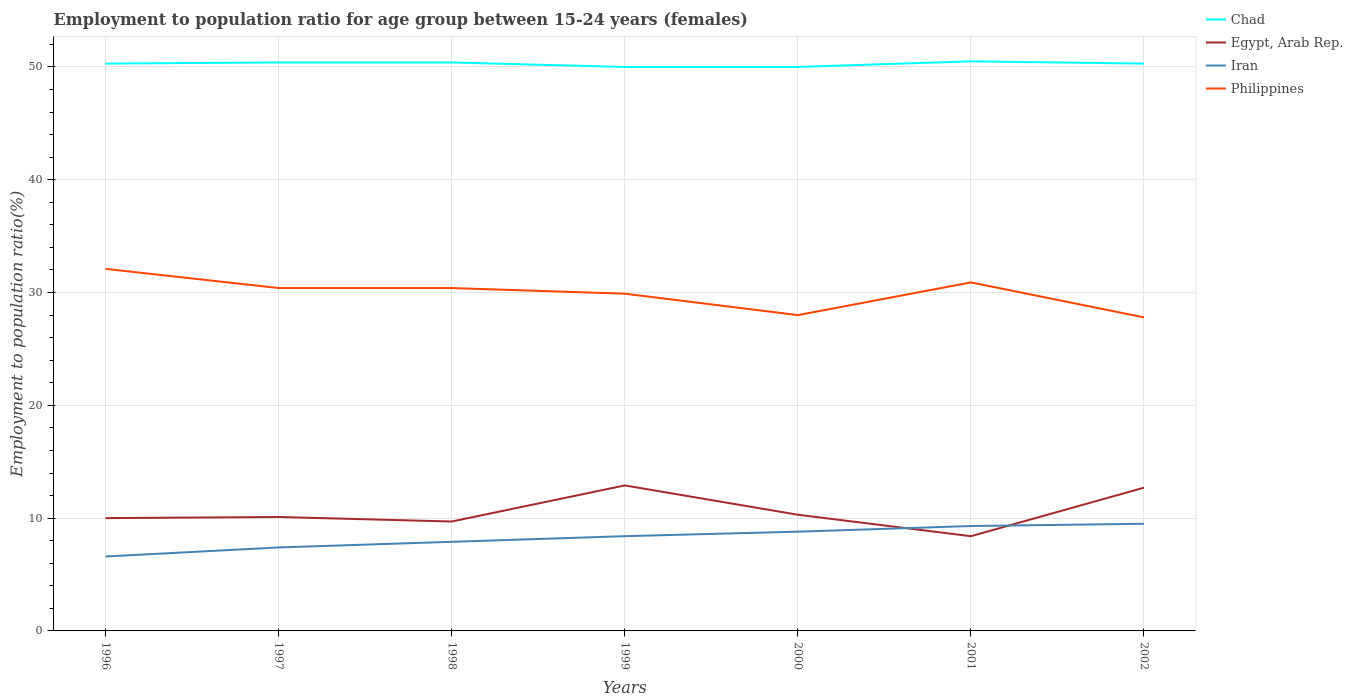How many different coloured lines are there?
Your response must be concise. 4. Across all years, what is the maximum employment to population ratio in Iran?
Give a very brief answer. 6.6. In which year was the employment to population ratio in Iran maximum?
Offer a very short reply. 1996. What is the total employment to population ratio in Egypt, Arab Rep. in the graph?
Provide a succinct answer. 4.5. What is the difference between the highest and the second highest employment to population ratio in Iran?
Provide a short and direct response. 2.9. How many lines are there?
Make the answer very short. 4. How many years are there in the graph?
Offer a terse response. 7. What is the difference between two consecutive major ticks on the Y-axis?
Offer a very short reply. 10. Are the values on the major ticks of Y-axis written in scientific E-notation?
Make the answer very short. No. Does the graph contain any zero values?
Make the answer very short. No. How many legend labels are there?
Your answer should be compact. 4. What is the title of the graph?
Give a very brief answer. Employment to population ratio for age group between 15-24 years (females). What is the label or title of the X-axis?
Keep it short and to the point. Years. What is the label or title of the Y-axis?
Provide a short and direct response. Employment to population ratio(%). What is the Employment to population ratio(%) in Chad in 1996?
Ensure brevity in your answer.  50.3. What is the Employment to population ratio(%) of Egypt, Arab Rep. in 1996?
Keep it short and to the point. 10. What is the Employment to population ratio(%) in Iran in 1996?
Offer a very short reply. 6.6. What is the Employment to population ratio(%) of Philippines in 1996?
Provide a short and direct response. 32.1. What is the Employment to population ratio(%) of Chad in 1997?
Your answer should be compact. 50.4. What is the Employment to population ratio(%) in Egypt, Arab Rep. in 1997?
Give a very brief answer. 10.1. What is the Employment to population ratio(%) of Iran in 1997?
Offer a very short reply. 7.4. What is the Employment to population ratio(%) in Philippines in 1997?
Offer a terse response. 30.4. What is the Employment to population ratio(%) in Chad in 1998?
Your answer should be compact. 50.4. What is the Employment to population ratio(%) of Egypt, Arab Rep. in 1998?
Your response must be concise. 9.7. What is the Employment to population ratio(%) in Iran in 1998?
Make the answer very short. 7.9. What is the Employment to population ratio(%) of Philippines in 1998?
Provide a succinct answer. 30.4. What is the Employment to population ratio(%) of Chad in 1999?
Offer a very short reply. 50. What is the Employment to population ratio(%) of Egypt, Arab Rep. in 1999?
Offer a terse response. 12.9. What is the Employment to population ratio(%) of Iran in 1999?
Provide a succinct answer. 8.4. What is the Employment to population ratio(%) of Philippines in 1999?
Offer a terse response. 29.9. What is the Employment to population ratio(%) of Egypt, Arab Rep. in 2000?
Provide a succinct answer. 10.3. What is the Employment to population ratio(%) of Iran in 2000?
Ensure brevity in your answer.  8.8. What is the Employment to population ratio(%) in Chad in 2001?
Your response must be concise. 50.5. What is the Employment to population ratio(%) of Egypt, Arab Rep. in 2001?
Keep it short and to the point. 8.4. What is the Employment to population ratio(%) in Iran in 2001?
Make the answer very short. 9.3. What is the Employment to population ratio(%) of Philippines in 2001?
Ensure brevity in your answer.  30.9. What is the Employment to population ratio(%) of Chad in 2002?
Your answer should be very brief. 50.3. What is the Employment to population ratio(%) in Egypt, Arab Rep. in 2002?
Your answer should be compact. 12.7. What is the Employment to population ratio(%) of Iran in 2002?
Your answer should be compact. 9.5. What is the Employment to population ratio(%) of Philippines in 2002?
Your answer should be compact. 27.8. Across all years, what is the maximum Employment to population ratio(%) in Chad?
Your response must be concise. 50.5. Across all years, what is the maximum Employment to population ratio(%) in Egypt, Arab Rep.?
Provide a succinct answer. 12.9. Across all years, what is the maximum Employment to population ratio(%) of Iran?
Your answer should be very brief. 9.5. Across all years, what is the maximum Employment to population ratio(%) in Philippines?
Ensure brevity in your answer.  32.1. Across all years, what is the minimum Employment to population ratio(%) in Egypt, Arab Rep.?
Your response must be concise. 8.4. Across all years, what is the minimum Employment to population ratio(%) in Iran?
Your answer should be very brief. 6.6. Across all years, what is the minimum Employment to population ratio(%) in Philippines?
Keep it short and to the point. 27.8. What is the total Employment to population ratio(%) of Chad in the graph?
Provide a succinct answer. 351.9. What is the total Employment to population ratio(%) in Egypt, Arab Rep. in the graph?
Your answer should be compact. 74.1. What is the total Employment to population ratio(%) in Iran in the graph?
Keep it short and to the point. 57.9. What is the total Employment to population ratio(%) of Philippines in the graph?
Your answer should be compact. 209.5. What is the difference between the Employment to population ratio(%) of Chad in 1996 and that in 1997?
Give a very brief answer. -0.1. What is the difference between the Employment to population ratio(%) in Philippines in 1996 and that in 1997?
Offer a very short reply. 1.7. What is the difference between the Employment to population ratio(%) of Iran in 1996 and that in 1998?
Make the answer very short. -1.3. What is the difference between the Employment to population ratio(%) in Philippines in 1996 and that in 1998?
Offer a very short reply. 1.7. What is the difference between the Employment to population ratio(%) in Chad in 1996 and that in 1999?
Provide a short and direct response. 0.3. What is the difference between the Employment to population ratio(%) of Iran in 1996 and that in 1999?
Your response must be concise. -1.8. What is the difference between the Employment to population ratio(%) of Philippines in 1996 and that in 2000?
Provide a short and direct response. 4.1. What is the difference between the Employment to population ratio(%) of Philippines in 1996 and that in 2001?
Your response must be concise. 1.2. What is the difference between the Employment to population ratio(%) in Chad in 1996 and that in 2002?
Offer a terse response. 0. What is the difference between the Employment to population ratio(%) in Iran in 1996 and that in 2002?
Make the answer very short. -2.9. What is the difference between the Employment to population ratio(%) in Chad in 1997 and that in 1998?
Your answer should be compact. 0. What is the difference between the Employment to population ratio(%) of Philippines in 1997 and that in 1998?
Offer a terse response. 0. What is the difference between the Employment to population ratio(%) in Chad in 1997 and that in 1999?
Ensure brevity in your answer.  0.4. What is the difference between the Employment to population ratio(%) of Egypt, Arab Rep. in 1997 and that in 1999?
Provide a short and direct response. -2.8. What is the difference between the Employment to population ratio(%) in Philippines in 1997 and that in 1999?
Provide a succinct answer. 0.5. What is the difference between the Employment to population ratio(%) of Chad in 1997 and that in 2000?
Your answer should be very brief. 0.4. What is the difference between the Employment to population ratio(%) in Egypt, Arab Rep. in 1997 and that in 2000?
Offer a very short reply. -0.2. What is the difference between the Employment to population ratio(%) of Iran in 1997 and that in 2000?
Give a very brief answer. -1.4. What is the difference between the Employment to population ratio(%) of Philippines in 1997 and that in 2001?
Your answer should be very brief. -0.5. What is the difference between the Employment to population ratio(%) in Chad in 1997 and that in 2002?
Offer a terse response. 0.1. What is the difference between the Employment to population ratio(%) of Egypt, Arab Rep. in 1997 and that in 2002?
Offer a very short reply. -2.6. What is the difference between the Employment to population ratio(%) of Philippines in 1997 and that in 2002?
Offer a very short reply. 2.6. What is the difference between the Employment to population ratio(%) in Egypt, Arab Rep. in 1998 and that in 1999?
Provide a short and direct response. -3.2. What is the difference between the Employment to population ratio(%) in Iran in 1998 and that in 1999?
Give a very brief answer. -0.5. What is the difference between the Employment to population ratio(%) of Philippines in 1998 and that in 1999?
Provide a short and direct response. 0.5. What is the difference between the Employment to population ratio(%) in Chad in 1998 and that in 2000?
Offer a very short reply. 0.4. What is the difference between the Employment to population ratio(%) of Chad in 1998 and that in 2001?
Keep it short and to the point. -0.1. What is the difference between the Employment to population ratio(%) in Egypt, Arab Rep. in 1998 and that in 2001?
Make the answer very short. 1.3. What is the difference between the Employment to population ratio(%) of Iran in 1998 and that in 2001?
Give a very brief answer. -1.4. What is the difference between the Employment to population ratio(%) of Iran in 1998 and that in 2002?
Provide a short and direct response. -1.6. What is the difference between the Employment to population ratio(%) in Egypt, Arab Rep. in 1999 and that in 2000?
Give a very brief answer. 2.6. What is the difference between the Employment to population ratio(%) of Iran in 1999 and that in 2000?
Your response must be concise. -0.4. What is the difference between the Employment to population ratio(%) in Philippines in 1999 and that in 2000?
Make the answer very short. 1.9. What is the difference between the Employment to population ratio(%) in Chad in 1999 and that in 2001?
Your response must be concise. -0.5. What is the difference between the Employment to population ratio(%) in Egypt, Arab Rep. in 1999 and that in 2002?
Provide a short and direct response. 0.2. What is the difference between the Employment to population ratio(%) of Iran in 1999 and that in 2002?
Ensure brevity in your answer.  -1.1. What is the difference between the Employment to population ratio(%) of Iran in 2000 and that in 2001?
Make the answer very short. -0.5. What is the difference between the Employment to population ratio(%) in Philippines in 2000 and that in 2001?
Make the answer very short. -2.9. What is the difference between the Employment to population ratio(%) of Chad in 2000 and that in 2002?
Ensure brevity in your answer.  -0.3. What is the difference between the Employment to population ratio(%) in Iran in 2000 and that in 2002?
Provide a short and direct response. -0.7. What is the difference between the Employment to population ratio(%) in Philippines in 2000 and that in 2002?
Provide a short and direct response. 0.2. What is the difference between the Employment to population ratio(%) in Egypt, Arab Rep. in 2001 and that in 2002?
Offer a terse response. -4.3. What is the difference between the Employment to population ratio(%) of Chad in 1996 and the Employment to population ratio(%) of Egypt, Arab Rep. in 1997?
Offer a very short reply. 40.2. What is the difference between the Employment to population ratio(%) of Chad in 1996 and the Employment to population ratio(%) of Iran in 1997?
Your answer should be compact. 42.9. What is the difference between the Employment to population ratio(%) in Chad in 1996 and the Employment to population ratio(%) in Philippines in 1997?
Provide a succinct answer. 19.9. What is the difference between the Employment to population ratio(%) of Egypt, Arab Rep. in 1996 and the Employment to population ratio(%) of Philippines in 1997?
Your answer should be compact. -20.4. What is the difference between the Employment to population ratio(%) of Iran in 1996 and the Employment to population ratio(%) of Philippines in 1997?
Provide a short and direct response. -23.8. What is the difference between the Employment to population ratio(%) in Chad in 1996 and the Employment to population ratio(%) in Egypt, Arab Rep. in 1998?
Provide a succinct answer. 40.6. What is the difference between the Employment to population ratio(%) in Chad in 1996 and the Employment to population ratio(%) in Iran in 1998?
Provide a succinct answer. 42.4. What is the difference between the Employment to population ratio(%) of Chad in 1996 and the Employment to population ratio(%) of Philippines in 1998?
Your answer should be very brief. 19.9. What is the difference between the Employment to population ratio(%) in Egypt, Arab Rep. in 1996 and the Employment to population ratio(%) in Iran in 1998?
Keep it short and to the point. 2.1. What is the difference between the Employment to population ratio(%) of Egypt, Arab Rep. in 1996 and the Employment to population ratio(%) of Philippines in 1998?
Your answer should be compact. -20.4. What is the difference between the Employment to population ratio(%) of Iran in 1996 and the Employment to population ratio(%) of Philippines in 1998?
Your response must be concise. -23.8. What is the difference between the Employment to population ratio(%) in Chad in 1996 and the Employment to population ratio(%) in Egypt, Arab Rep. in 1999?
Your answer should be very brief. 37.4. What is the difference between the Employment to population ratio(%) in Chad in 1996 and the Employment to population ratio(%) in Iran in 1999?
Your answer should be compact. 41.9. What is the difference between the Employment to population ratio(%) of Chad in 1996 and the Employment to population ratio(%) of Philippines in 1999?
Give a very brief answer. 20.4. What is the difference between the Employment to population ratio(%) in Egypt, Arab Rep. in 1996 and the Employment to population ratio(%) in Iran in 1999?
Offer a very short reply. 1.6. What is the difference between the Employment to population ratio(%) of Egypt, Arab Rep. in 1996 and the Employment to population ratio(%) of Philippines in 1999?
Make the answer very short. -19.9. What is the difference between the Employment to population ratio(%) in Iran in 1996 and the Employment to population ratio(%) in Philippines in 1999?
Make the answer very short. -23.3. What is the difference between the Employment to population ratio(%) in Chad in 1996 and the Employment to population ratio(%) in Iran in 2000?
Your response must be concise. 41.5. What is the difference between the Employment to population ratio(%) in Chad in 1996 and the Employment to population ratio(%) in Philippines in 2000?
Provide a succinct answer. 22.3. What is the difference between the Employment to population ratio(%) in Egypt, Arab Rep. in 1996 and the Employment to population ratio(%) in Iran in 2000?
Offer a very short reply. 1.2. What is the difference between the Employment to population ratio(%) in Egypt, Arab Rep. in 1996 and the Employment to population ratio(%) in Philippines in 2000?
Give a very brief answer. -18. What is the difference between the Employment to population ratio(%) of Iran in 1996 and the Employment to population ratio(%) of Philippines in 2000?
Ensure brevity in your answer.  -21.4. What is the difference between the Employment to population ratio(%) in Chad in 1996 and the Employment to population ratio(%) in Egypt, Arab Rep. in 2001?
Keep it short and to the point. 41.9. What is the difference between the Employment to population ratio(%) of Chad in 1996 and the Employment to population ratio(%) of Iran in 2001?
Ensure brevity in your answer.  41. What is the difference between the Employment to population ratio(%) in Chad in 1996 and the Employment to population ratio(%) in Philippines in 2001?
Your answer should be compact. 19.4. What is the difference between the Employment to population ratio(%) of Egypt, Arab Rep. in 1996 and the Employment to population ratio(%) of Philippines in 2001?
Offer a terse response. -20.9. What is the difference between the Employment to population ratio(%) in Iran in 1996 and the Employment to population ratio(%) in Philippines in 2001?
Your answer should be very brief. -24.3. What is the difference between the Employment to population ratio(%) of Chad in 1996 and the Employment to population ratio(%) of Egypt, Arab Rep. in 2002?
Offer a terse response. 37.6. What is the difference between the Employment to population ratio(%) of Chad in 1996 and the Employment to population ratio(%) of Iran in 2002?
Give a very brief answer. 40.8. What is the difference between the Employment to population ratio(%) of Chad in 1996 and the Employment to population ratio(%) of Philippines in 2002?
Keep it short and to the point. 22.5. What is the difference between the Employment to population ratio(%) of Egypt, Arab Rep. in 1996 and the Employment to population ratio(%) of Iran in 2002?
Your answer should be very brief. 0.5. What is the difference between the Employment to population ratio(%) in Egypt, Arab Rep. in 1996 and the Employment to population ratio(%) in Philippines in 2002?
Your answer should be very brief. -17.8. What is the difference between the Employment to population ratio(%) in Iran in 1996 and the Employment to population ratio(%) in Philippines in 2002?
Provide a succinct answer. -21.2. What is the difference between the Employment to population ratio(%) in Chad in 1997 and the Employment to population ratio(%) in Egypt, Arab Rep. in 1998?
Give a very brief answer. 40.7. What is the difference between the Employment to population ratio(%) in Chad in 1997 and the Employment to population ratio(%) in Iran in 1998?
Provide a short and direct response. 42.5. What is the difference between the Employment to population ratio(%) of Chad in 1997 and the Employment to population ratio(%) of Philippines in 1998?
Ensure brevity in your answer.  20. What is the difference between the Employment to population ratio(%) in Egypt, Arab Rep. in 1997 and the Employment to population ratio(%) in Iran in 1998?
Your answer should be very brief. 2.2. What is the difference between the Employment to population ratio(%) of Egypt, Arab Rep. in 1997 and the Employment to population ratio(%) of Philippines in 1998?
Keep it short and to the point. -20.3. What is the difference between the Employment to population ratio(%) in Chad in 1997 and the Employment to population ratio(%) in Egypt, Arab Rep. in 1999?
Your answer should be compact. 37.5. What is the difference between the Employment to population ratio(%) of Chad in 1997 and the Employment to population ratio(%) of Iran in 1999?
Keep it short and to the point. 42. What is the difference between the Employment to population ratio(%) in Egypt, Arab Rep. in 1997 and the Employment to population ratio(%) in Iran in 1999?
Offer a very short reply. 1.7. What is the difference between the Employment to population ratio(%) of Egypt, Arab Rep. in 1997 and the Employment to population ratio(%) of Philippines in 1999?
Your response must be concise. -19.8. What is the difference between the Employment to population ratio(%) of Iran in 1997 and the Employment to population ratio(%) of Philippines in 1999?
Your answer should be compact. -22.5. What is the difference between the Employment to population ratio(%) in Chad in 1997 and the Employment to population ratio(%) in Egypt, Arab Rep. in 2000?
Your response must be concise. 40.1. What is the difference between the Employment to population ratio(%) in Chad in 1997 and the Employment to population ratio(%) in Iran in 2000?
Ensure brevity in your answer.  41.6. What is the difference between the Employment to population ratio(%) in Chad in 1997 and the Employment to population ratio(%) in Philippines in 2000?
Offer a very short reply. 22.4. What is the difference between the Employment to population ratio(%) in Egypt, Arab Rep. in 1997 and the Employment to population ratio(%) in Philippines in 2000?
Your answer should be very brief. -17.9. What is the difference between the Employment to population ratio(%) of Iran in 1997 and the Employment to population ratio(%) of Philippines in 2000?
Your response must be concise. -20.6. What is the difference between the Employment to population ratio(%) in Chad in 1997 and the Employment to population ratio(%) in Iran in 2001?
Provide a succinct answer. 41.1. What is the difference between the Employment to population ratio(%) in Egypt, Arab Rep. in 1997 and the Employment to population ratio(%) in Iran in 2001?
Provide a short and direct response. 0.8. What is the difference between the Employment to population ratio(%) in Egypt, Arab Rep. in 1997 and the Employment to population ratio(%) in Philippines in 2001?
Provide a short and direct response. -20.8. What is the difference between the Employment to population ratio(%) of Iran in 1997 and the Employment to population ratio(%) of Philippines in 2001?
Your response must be concise. -23.5. What is the difference between the Employment to population ratio(%) in Chad in 1997 and the Employment to population ratio(%) in Egypt, Arab Rep. in 2002?
Your answer should be very brief. 37.7. What is the difference between the Employment to population ratio(%) of Chad in 1997 and the Employment to population ratio(%) of Iran in 2002?
Offer a terse response. 40.9. What is the difference between the Employment to population ratio(%) in Chad in 1997 and the Employment to population ratio(%) in Philippines in 2002?
Your answer should be very brief. 22.6. What is the difference between the Employment to population ratio(%) in Egypt, Arab Rep. in 1997 and the Employment to population ratio(%) in Iran in 2002?
Provide a short and direct response. 0.6. What is the difference between the Employment to population ratio(%) of Egypt, Arab Rep. in 1997 and the Employment to population ratio(%) of Philippines in 2002?
Offer a very short reply. -17.7. What is the difference between the Employment to population ratio(%) of Iran in 1997 and the Employment to population ratio(%) of Philippines in 2002?
Make the answer very short. -20.4. What is the difference between the Employment to population ratio(%) in Chad in 1998 and the Employment to population ratio(%) in Egypt, Arab Rep. in 1999?
Keep it short and to the point. 37.5. What is the difference between the Employment to population ratio(%) in Egypt, Arab Rep. in 1998 and the Employment to population ratio(%) in Philippines in 1999?
Make the answer very short. -20.2. What is the difference between the Employment to population ratio(%) of Iran in 1998 and the Employment to population ratio(%) of Philippines in 1999?
Your answer should be compact. -22. What is the difference between the Employment to population ratio(%) in Chad in 1998 and the Employment to population ratio(%) in Egypt, Arab Rep. in 2000?
Offer a terse response. 40.1. What is the difference between the Employment to population ratio(%) in Chad in 1998 and the Employment to population ratio(%) in Iran in 2000?
Give a very brief answer. 41.6. What is the difference between the Employment to population ratio(%) in Chad in 1998 and the Employment to population ratio(%) in Philippines in 2000?
Give a very brief answer. 22.4. What is the difference between the Employment to population ratio(%) of Egypt, Arab Rep. in 1998 and the Employment to population ratio(%) of Iran in 2000?
Provide a succinct answer. 0.9. What is the difference between the Employment to population ratio(%) of Egypt, Arab Rep. in 1998 and the Employment to population ratio(%) of Philippines in 2000?
Ensure brevity in your answer.  -18.3. What is the difference between the Employment to population ratio(%) of Iran in 1998 and the Employment to population ratio(%) of Philippines in 2000?
Keep it short and to the point. -20.1. What is the difference between the Employment to population ratio(%) of Chad in 1998 and the Employment to population ratio(%) of Iran in 2001?
Offer a terse response. 41.1. What is the difference between the Employment to population ratio(%) of Chad in 1998 and the Employment to population ratio(%) of Philippines in 2001?
Make the answer very short. 19.5. What is the difference between the Employment to population ratio(%) in Egypt, Arab Rep. in 1998 and the Employment to population ratio(%) in Iran in 2001?
Keep it short and to the point. 0.4. What is the difference between the Employment to population ratio(%) of Egypt, Arab Rep. in 1998 and the Employment to population ratio(%) of Philippines in 2001?
Provide a succinct answer. -21.2. What is the difference between the Employment to population ratio(%) of Iran in 1998 and the Employment to population ratio(%) of Philippines in 2001?
Make the answer very short. -23. What is the difference between the Employment to population ratio(%) of Chad in 1998 and the Employment to population ratio(%) of Egypt, Arab Rep. in 2002?
Your answer should be compact. 37.7. What is the difference between the Employment to population ratio(%) in Chad in 1998 and the Employment to population ratio(%) in Iran in 2002?
Give a very brief answer. 40.9. What is the difference between the Employment to population ratio(%) of Chad in 1998 and the Employment to population ratio(%) of Philippines in 2002?
Provide a short and direct response. 22.6. What is the difference between the Employment to population ratio(%) in Egypt, Arab Rep. in 1998 and the Employment to population ratio(%) in Iran in 2002?
Provide a short and direct response. 0.2. What is the difference between the Employment to population ratio(%) in Egypt, Arab Rep. in 1998 and the Employment to population ratio(%) in Philippines in 2002?
Ensure brevity in your answer.  -18.1. What is the difference between the Employment to population ratio(%) in Iran in 1998 and the Employment to population ratio(%) in Philippines in 2002?
Give a very brief answer. -19.9. What is the difference between the Employment to population ratio(%) of Chad in 1999 and the Employment to population ratio(%) of Egypt, Arab Rep. in 2000?
Provide a short and direct response. 39.7. What is the difference between the Employment to population ratio(%) in Chad in 1999 and the Employment to population ratio(%) in Iran in 2000?
Give a very brief answer. 41.2. What is the difference between the Employment to population ratio(%) in Chad in 1999 and the Employment to population ratio(%) in Philippines in 2000?
Your answer should be very brief. 22. What is the difference between the Employment to population ratio(%) of Egypt, Arab Rep. in 1999 and the Employment to population ratio(%) of Philippines in 2000?
Offer a terse response. -15.1. What is the difference between the Employment to population ratio(%) in Iran in 1999 and the Employment to population ratio(%) in Philippines in 2000?
Give a very brief answer. -19.6. What is the difference between the Employment to population ratio(%) in Chad in 1999 and the Employment to population ratio(%) in Egypt, Arab Rep. in 2001?
Your answer should be compact. 41.6. What is the difference between the Employment to population ratio(%) in Chad in 1999 and the Employment to population ratio(%) in Iran in 2001?
Make the answer very short. 40.7. What is the difference between the Employment to population ratio(%) in Chad in 1999 and the Employment to population ratio(%) in Philippines in 2001?
Your response must be concise. 19.1. What is the difference between the Employment to population ratio(%) of Egypt, Arab Rep. in 1999 and the Employment to population ratio(%) of Iran in 2001?
Offer a terse response. 3.6. What is the difference between the Employment to population ratio(%) of Iran in 1999 and the Employment to population ratio(%) of Philippines in 2001?
Provide a succinct answer. -22.5. What is the difference between the Employment to population ratio(%) in Chad in 1999 and the Employment to population ratio(%) in Egypt, Arab Rep. in 2002?
Provide a succinct answer. 37.3. What is the difference between the Employment to population ratio(%) of Chad in 1999 and the Employment to population ratio(%) of Iran in 2002?
Give a very brief answer. 40.5. What is the difference between the Employment to population ratio(%) of Chad in 1999 and the Employment to population ratio(%) of Philippines in 2002?
Your answer should be very brief. 22.2. What is the difference between the Employment to population ratio(%) of Egypt, Arab Rep. in 1999 and the Employment to population ratio(%) of Philippines in 2002?
Offer a very short reply. -14.9. What is the difference between the Employment to population ratio(%) of Iran in 1999 and the Employment to population ratio(%) of Philippines in 2002?
Make the answer very short. -19.4. What is the difference between the Employment to population ratio(%) in Chad in 2000 and the Employment to population ratio(%) in Egypt, Arab Rep. in 2001?
Keep it short and to the point. 41.6. What is the difference between the Employment to population ratio(%) in Chad in 2000 and the Employment to population ratio(%) in Iran in 2001?
Your answer should be compact. 40.7. What is the difference between the Employment to population ratio(%) of Egypt, Arab Rep. in 2000 and the Employment to population ratio(%) of Iran in 2001?
Provide a short and direct response. 1. What is the difference between the Employment to population ratio(%) in Egypt, Arab Rep. in 2000 and the Employment to population ratio(%) in Philippines in 2001?
Offer a very short reply. -20.6. What is the difference between the Employment to population ratio(%) of Iran in 2000 and the Employment to population ratio(%) of Philippines in 2001?
Your response must be concise. -22.1. What is the difference between the Employment to population ratio(%) in Chad in 2000 and the Employment to population ratio(%) in Egypt, Arab Rep. in 2002?
Your answer should be compact. 37.3. What is the difference between the Employment to population ratio(%) of Chad in 2000 and the Employment to population ratio(%) of Iran in 2002?
Your answer should be very brief. 40.5. What is the difference between the Employment to population ratio(%) in Egypt, Arab Rep. in 2000 and the Employment to population ratio(%) in Philippines in 2002?
Provide a succinct answer. -17.5. What is the difference between the Employment to population ratio(%) in Chad in 2001 and the Employment to population ratio(%) in Egypt, Arab Rep. in 2002?
Provide a succinct answer. 37.8. What is the difference between the Employment to population ratio(%) of Chad in 2001 and the Employment to population ratio(%) of Iran in 2002?
Your answer should be very brief. 41. What is the difference between the Employment to population ratio(%) in Chad in 2001 and the Employment to population ratio(%) in Philippines in 2002?
Give a very brief answer. 22.7. What is the difference between the Employment to population ratio(%) in Egypt, Arab Rep. in 2001 and the Employment to population ratio(%) in Iran in 2002?
Offer a terse response. -1.1. What is the difference between the Employment to population ratio(%) of Egypt, Arab Rep. in 2001 and the Employment to population ratio(%) of Philippines in 2002?
Ensure brevity in your answer.  -19.4. What is the difference between the Employment to population ratio(%) of Iran in 2001 and the Employment to population ratio(%) of Philippines in 2002?
Your answer should be compact. -18.5. What is the average Employment to population ratio(%) in Chad per year?
Your response must be concise. 50.27. What is the average Employment to population ratio(%) in Egypt, Arab Rep. per year?
Keep it short and to the point. 10.59. What is the average Employment to population ratio(%) in Iran per year?
Provide a short and direct response. 8.27. What is the average Employment to population ratio(%) in Philippines per year?
Your answer should be compact. 29.93. In the year 1996, what is the difference between the Employment to population ratio(%) in Chad and Employment to population ratio(%) in Egypt, Arab Rep.?
Your answer should be compact. 40.3. In the year 1996, what is the difference between the Employment to population ratio(%) in Chad and Employment to population ratio(%) in Iran?
Your answer should be very brief. 43.7. In the year 1996, what is the difference between the Employment to population ratio(%) of Egypt, Arab Rep. and Employment to population ratio(%) of Philippines?
Keep it short and to the point. -22.1. In the year 1996, what is the difference between the Employment to population ratio(%) of Iran and Employment to population ratio(%) of Philippines?
Make the answer very short. -25.5. In the year 1997, what is the difference between the Employment to population ratio(%) in Chad and Employment to population ratio(%) in Egypt, Arab Rep.?
Your response must be concise. 40.3. In the year 1997, what is the difference between the Employment to population ratio(%) of Chad and Employment to population ratio(%) of Philippines?
Provide a short and direct response. 20. In the year 1997, what is the difference between the Employment to population ratio(%) in Egypt, Arab Rep. and Employment to population ratio(%) in Iran?
Provide a succinct answer. 2.7. In the year 1997, what is the difference between the Employment to population ratio(%) of Egypt, Arab Rep. and Employment to population ratio(%) of Philippines?
Your answer should be very brief. -20.3. In the year 1998, what is the difference between the Employment to population ratio(%) in Chad and Employment to population ratio(%) in Egypt, Arab Rep.?
Give a very brief answer. 40.7. In the year 1998, what is the difference between the Employment to population ratio(%) of Chad and Employment to population ratio(%) of Iran?
Keep it short and to the point. 42.5. In the year 1998, what is the difference between the Employment to population ratio(%) in Chad and Employment to population ratio(%) in Philippines?
Your response must be concise. 20. In the year 1998, what is the difference between the Employment to population ratio(%) of Egypt, Arab Rep. and Employment to population ratio(%) of Iran?
Ensure brevity in your answer.  1.8. In the year 1998, what is the difference between the Employment to population ratio(%) in Egypt, Arab Rep. and Employment to population ratio(%) in Philippines?
Provide a short and direct response. -20.7. In the year 1998, what is the difference between the Employment to population ratio(%) of Iran and Employment to population ratio(%) of Philippines?
Your response must be concise. -22.5. In the year 1999, what is the difference between the Employment to population ratio(%) in Chad and Employment to population ratio(%) in Egypt, Arab Rep.?
Offer a very short reply. 37.1. In the year 1999, what is the difference between the Employment to population ratio(%) in Chad and Employment to population ratio(%) in Iran?
Keep it short and to the point. 41.6. In the year 1999, what is the difference between the Employment to population ratio(%) in Chad and Employment to population ratio(%) in Philippines?
Keep it short and to the point. 20.1. In the year 1999, what is the difference between the Employment to population ratio(%) of Egypt, Arab Rep. and Employment to population ratio(%) of Iran?
Offer a very short reply. 4.5. In the year 1999, what is the difference between the Employment to population ratio(%) of Egypt, Arab Rep. and Employment to population ratio(%) of Philippines?
Your answer should be compact. -17. In the year 1999, what is the difference between the Employment to population ratio(%) in Iran and Employment to population ratio(%) in Philippines?
Ensure brevity in your answer.  -21.5. In the year 2000, what is the difference between the Employment to population ratio(%) in Chad and Employment to population ratio(%) in Egypt, Arab Rep.?
Your answer should be very brief. 39.7. In the year 2000, what is the difference between the Employment to population ratio(%) of Chad and Employment to population ratio(%) of Iran?
Your answer should be very brief. 41.2. In the year 2000, what is the difference between the Employment to population ratio(%) of Egypt, Arab Rep. and Employment to population ratio(%) of Philippines?
Keep it short and to the point. -17.7. In the year 2000, what is the difference between the Employment to population ratio(%) of Iran and Employment to population ratio(%) of Philippines?
Make the answer very short. -19.2. In the year 2001, what is the difference between the Employment to population ratio(%) in Chad and Employment to population ratio(%) in Egypt, Arab Rep.?
Provide a succinct answer. 42.1. In the year 2001, what is the difference between the Employment to population ratio(%) of Chad and Employment to population ratio(%) of Iran?
Your response must be concise. 41.2. In the year 2001, what is the difference between the Employment to population ratio(%) in Chad and Employment to population ratio(%) in Philippines?
Ensure brevity in your answer.  19.6. In the year 2001, what is the difference between the Employment to population ratio(%) of Egypt, Arab Rep. and Employment to population ratio(%) of Philippines?
Provide a succinct answer. -22.5. In the year 2001, what is the difference between the Employment to population ratio(%) of Iran and Employment to population ratio(%) of Philippines?
Provide a short and direct response. -21.6. In the year 2002, what is the difference between the Employment to population ratio(%) in Chad and Employment to population ratio(%) in Egypt, Arab Rep.?
Ensure brevity in your answer.  37.6. In the year 2002, what is the difference between the Employment to population ratio(%) in Chad and Employment to population ratio(%) in Iran?
Make the answer very short. 40.8. In the year 2002, what is the difference between the Employment to population ratio(%) of Egypt, Arab Rep. and Employment to population ratio(%) of Iran?
Offer a very short reply. 3.2. In the year 2002, what is the difference between the Employment to population ratio(%) of Egypt, Arab Rep. and Employment to population ratio(%) of Philippines?
Your response must be concise. -15.1. In the year 2002, what is the difference between the Employment to population ratio(%) in Iran and Employment to population ratio(%) in Philippines?
Your response must be concise. -18.3. What is the ratio of the Employment to population ratio(%) in Iran in 1996 to that in 1997?
Your answer should be very brief. 0.89. What is the ratio of the Employment to population ratio(%) of Philippines in 1996 to that in 1997?
Your response must be concise. 1.06. What is the ratio of the Employment to population ratio(%) of Chad in 1996 to that in 1998?
Make the answer very short. 1. What is the ratio of the Employment to population ratio(%) in Egypt, Arab Rep. in 1996 to that in 1998?
Keep it short and to the point. 1.03. What is the ratio of the Employment to population ratio(%) of Iran in 1996 to that in 1998?
Give a very brief answer. 0.84. What is the ratio of the Employment to population ratio(%) in Philippines in 1996 to that in 1998?
Ensure brevity in your answer.  1.06. What is the ratio of the Employment to population ratio(%) in Egypt, Arab Rep. in 1996 to that in 1999?
Keep it short and to the point. 0.78. What is the ratio of the Employment to population ratio(%) in Iran in 1996 to that in 1999?
Provide a succinct answer. 0.79. What is the ratio of the Employment to population ratio(%) in Philippines in 1996 to that in 1999?
Offer a terse response. 1.07. What is the ratio of the Employment to population ratio(%) in Egypt, Arab Rep. in 1996 to that in 2000?
Offer a very short reply. 0.97. What is the ratio of the Employment to population ratio(%) in Philippines in 1996 to that in 2000?
Ensure brevity in your answer.  1.15. What is the ratio of the Employment to population ratio(%) in Chad in 1996 to that in 2001?
Provide a short and direct response. 1. What is the ratio of the Employment to population ratio(%) in Egypt, Arab Rep. in 1996 to that in 2001?
Offer a very short reply. 1.19. What is the ratio of the Employment to population ratio(%) of Iran in 1996 to that in 2001?
Keep it short and to the point. 0.71. What is the ratio of the Employment to population ratio(%) of Philippines in 1996 to that in 2001?
Make the answer very short. 1.04. What is the ratio of the Employment to population ratio(%) of Chad in 1996 to that in 2002?
Provide a succinct answer. 1. What is the ratio of the Employment to population ratio(%) in Egypt, Arab Rep. in 1996 to that in 2002?
Provide a short and direct response. 0.79. What is the ratio of the Employment to population ratio(%) in Iran in 1996 to that in 2002?
Make the answer very short. 0.69. What is the ratio of the Employment to population ratio(%) in Philippines in 1996 to that in 2002?
Your answer should be very brief. 1.15. What is the ratio of the Employment to population ratio(%) of Chad in 1997 to that in 1998?
Provide a short and direct response. 1. What is the ratio of the Employment to population ratio(%) in Egypt, Arab Rep. in 1997 to that in 1998?
Keep it short and to the point. 1.04. What is the ratio of the Employment to population ratio(%) in Iran in 1997 to that in 1998?
Give a very brief answer. 0.94. What is the ratio of the Employment to population ratio(%) of Philippines in 1997 to that in 1998?
Offer a terse response. 1. What is the ratio of the Employment to population ratio(%) in Egypt, Arab Rep. in 1997 to that in 1999?
Ensure brevity in your answer.  0.78. What is the ratio of the Employment to population ratio(%) of Iran in 1997 to that in 1999?
Offer a terse response. 0.88. What is the ratio of the Employment to population ratio(%) in Philippines in 1997 to that in 1999?
Your answer should be very brief. 1.02. What is the ratio of the Employment to population ratio(%) of Chad in 1997 to that in 2000?
Provide a short and direct response. 1.01. What is the ratio of the Employment to population ratio(%) of Egypt, Arab Rep. in 1997 to that in 2000?
Your response must be concise. 0.98. What is the ratio of the Employment to population ratio(%) of Iran in 1997 to that in 2000?
Make the answer very short. 0.84. What is the ratio of the Employment to population ratio(%) of Philippines in 1997 to that in 2000?
Make the answer very short. 1.09. What is the ratio of the Employment to population ratio(%) of Egypt, Arab Rep. in 1997 to that in 2001?
Offer a terse response. 1.2. What is the ratio of the Employment to population ratio(%) in Iran in 1997 to that in 2001?
Give a very brief answer. 0.8. What is the ratio of the Employment to population ratio(%) in Philippines in 1997 to that in 2001?
Make the answer very short. 0.98. What is the ratio of the Employment to population ratio(%) in Chad in 1997 to that in 2002?
Your response must be concise. 1. What is the ratio of the Employment to population ratio(%) in Egypt, Arab Rep. in 1997 to that in 2002?
Your answer should be compact. 0.8. What is the ratio of the Employment to population ratio(%) in Iran in 1997 to that in 2002?
Provide a short and direct response. 0.78. What is the ratio of the Employment to population ratio(%) of Philippines in 1997 to that in 2002?
Your answer should be compact. 1.09. What is the ratio of the Employment to population ratio(%) of Egypt, Arab Rep. in 1998 to that in 1999?
Provide a succinct answer. 0.75. What is the ratio of the Employment to population ratio(%) in Iran in 1998 to that in 1999?
Keep it short and to the point. 0.94. What is the ratio of the Employment to population ratio(%) in Philippines in 1998 to that in 1999?
Provide a succinct answer. 1.02. What is the ratio of the Employment to population ratio(%) in Egypt, Arab Rep. in 1998 to that in 2000?
Your answer should be compact. 0.94. What is the ratio of the Employment to population ratio(%) of Iran in 1998 to that in 2000?
Your response must be concise. 0.9. What is the ratio of the Employment to population ratio(%) of Philippines in 1998 to that in 2000?
Ensure brevity in your answer.  1.09. What is the ratio of the Employment to population ratio(%) in Egypt, Arab Rep. in 1998 to that in 2001?
Provide a short and direct response. 1.15. What is the ratio of the Employment to population ratio(%) in Iran in 1998 to that in 2001?
Keep it short and to the point. 0.85. What is the ratio of the Employment to population ratio(%) in Philippines in 1998 to that in 2001?
Provide a short and direct response. 0.98. What is the ratio of the Employment to population ratio(%) in Egypt, Arab Rep. in 1998 to that in 2002?
Keep it short and to the point. 0.76. What is the ratio of the Employment to population ratio(%) of Iran in 1998 to that in 2002?
Your response must be concise. 0.83. What is the ratio of the Employment to population ratio(%) of Philippines in 1998 to that in 2002?
Keep it short and to the point. 1.09. What is the ratio of the Employment to population ratio(%) of Egypt, Arab Rep. in 1999 to that in 2000?
Your answer should be compact. 1.25. What is the ratio of the Employment to population ratio(%) in Iran in 1999 to that in 2000?
Ensure brevity in your answer.  0.95. What is the ratio of the Employment to population ratio(%) in Philippines in 1999 to that in 2000?
Your answer should be very brief. 1.07. What is the ratio of the Employment to population ratio(%) in Egypt, Arab Rep. in 1999 to that in 2001?
Your answer should be compact. 1.54. What is the ratio of the Employment to population ratio(%) in Iran in 1999 to that in 2001?
Provide a succinct answer. 0.9. What is the ratio of the Employment to population ratio(%) in Philippines in 1999 to that in 2001?
Offer a very short reply. 0.97. What is the ratio of the Employment to population ratio(%) in Chad in 1999 to that in 2002?
Give a very brief answer. 0.99. What is the ratio of the Employment to population ratio(%) in Egypt, Arab Rep. in 1999 to that in 2002?
Offer a terse response. 1.02. What is the ratio of the Employment to population ratio(%) of Iran in 1999 to that in 2002?
Offer a very short reply. 0.88. What is the ratio of the Employment to population ratio(%) of Philippines in 1999 to that in 2002?
Your answer should be very brief. 1.08. What is the ratio of the Employment to population ratio(%) in Chad in 2000 to that in 2001?
Offer a very short reply. 0.99. What is the ratio of the Employment to population ratio(%) in Egypt, Arab Rep. in 2000 to that in 2001?
Offer a terse response. 1.23. What is the ratio of the Employment to population ratio(%) in Iran in 2000 to that in 2001?
Provide a short and direct response. 0.95. What is the ratio of the Employment to population ratio(%) in Philippines in 2000 to that in 2001?
Provide a short and direct response. 0.91. What is the ratio of the Employment to population ratio(%) of Egypt, Arab Rep. in 2000 to that in 2002?
Offer a very short reply. 0.81. What is the ratio of the Employment to population ratio(%) in Iran in 2000 to that in 2002?
Offer a very short reply. 0.93. What is the ratio of the Employment to population ratio(%) in Chad in 2001 to that in 2002?
Offer a very short reply. 1. What is the ratio of the Employment to population ratio(%) in Egypt, Arab Rep. in 2001 to that in 2002?
Provide a short and direct response. 0.66. What is the ratio of the Employment to population ratio(%) in Iran in 2001 to that in 2002?
Offer a terse response. 0.98. What is the ratio of the Employment to population ratio(%) in Philippines in 2001 to that in 2002?
Give a very brief answer. 1.11. What is the difference between the highest and the second highest Employment to population ratio(%) of Chad?
Ensure brevity in your answer.  0.1. What is the difference between the highest and the second highest Employment to population ratio(%) of Egypt, Arab Rep.?
Your answer should be compact. 0.2. What is the difference between the highest and the lowest Employment to population ratio(%) of Egypt, Arab Rep.?
Provide a short and direct response. 4.5. What is the difference between the highest and the lowest Employment to population ratio(%) in Philippines?
Your answer should be very brief. 4.3. 